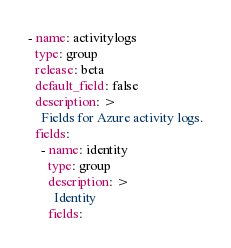<code> <loc_0><loc_0><loc_500><loc_500><_YAML_>- name: activitylogs
  type: group
  release: beta
  default_field: false
  description: >
    Fields for Azure activity logs.
  fields:
    - name: identity
      type: group
      description: >
        Identity
      fields:</code> 